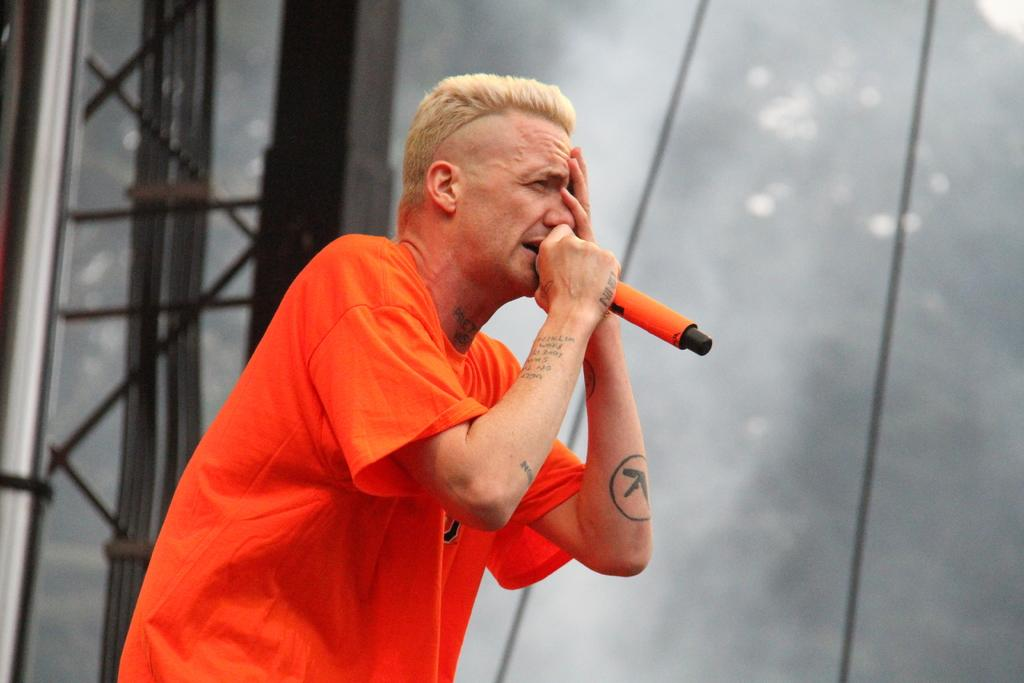What is the man in the image doing? The man is singing in the image. What is the man using to amplify his voice? The man is using a wireless microphone in the image. What color is the t-shirt the man is wearing? The man is wearing an orange t-shirt in the image. Are there any boats or veils visible in the image? No, there are no boats or veils present in the image. 